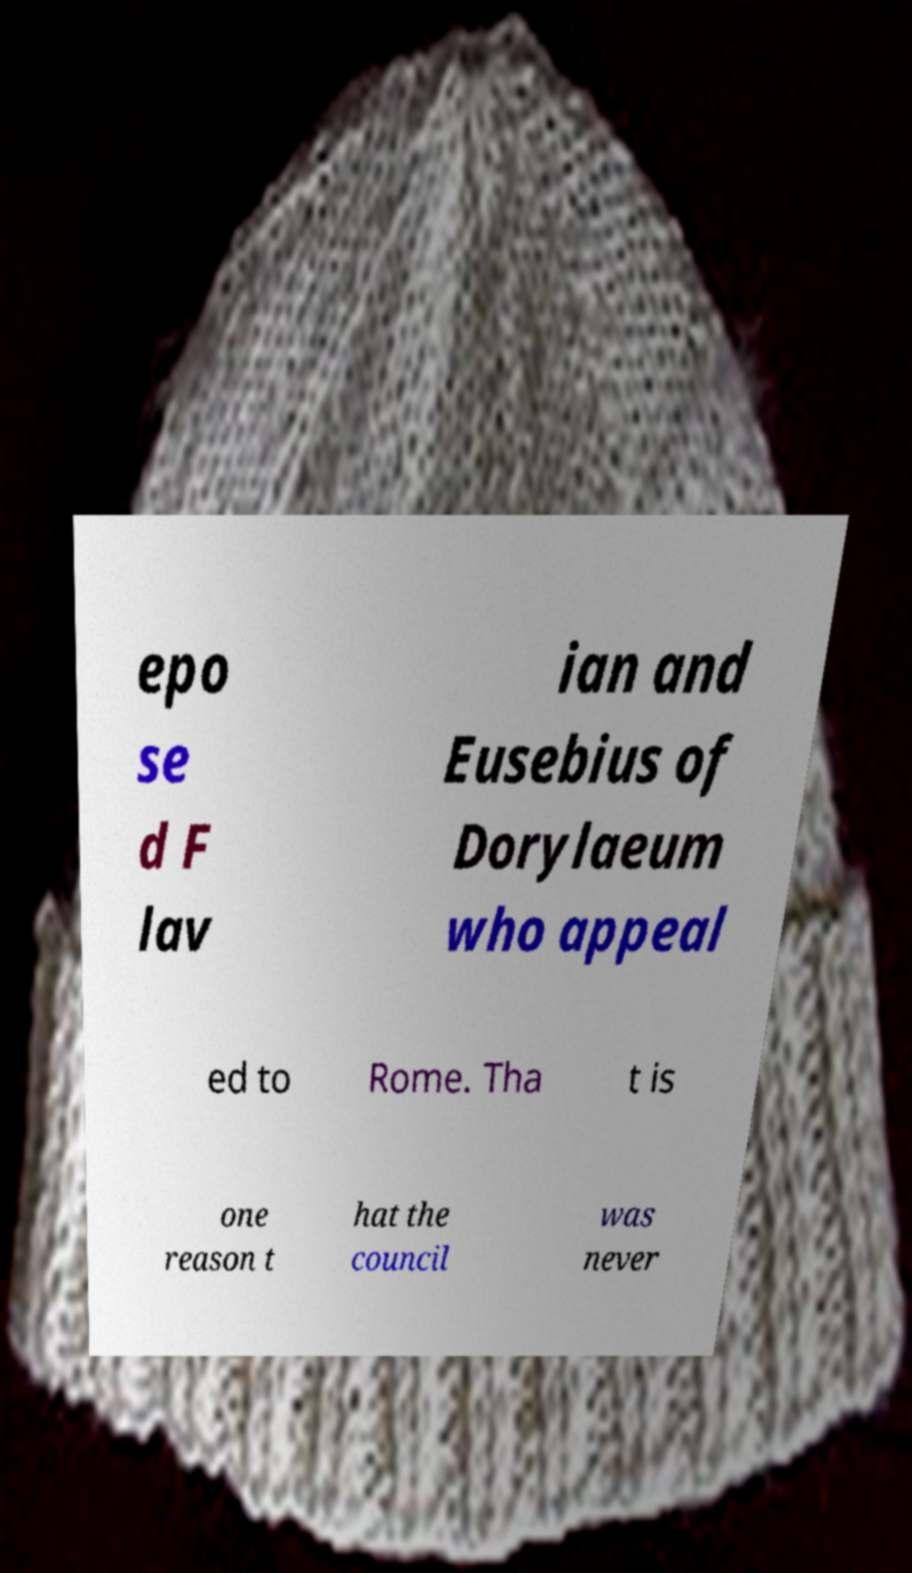There's text embedded in this image that I need extracted. Can you transcribe it verbatim? epo se d F lav ian and Eusebius of Dorylaeum who appeal ed to Rome. Tha t is one reason t hat the council was never 